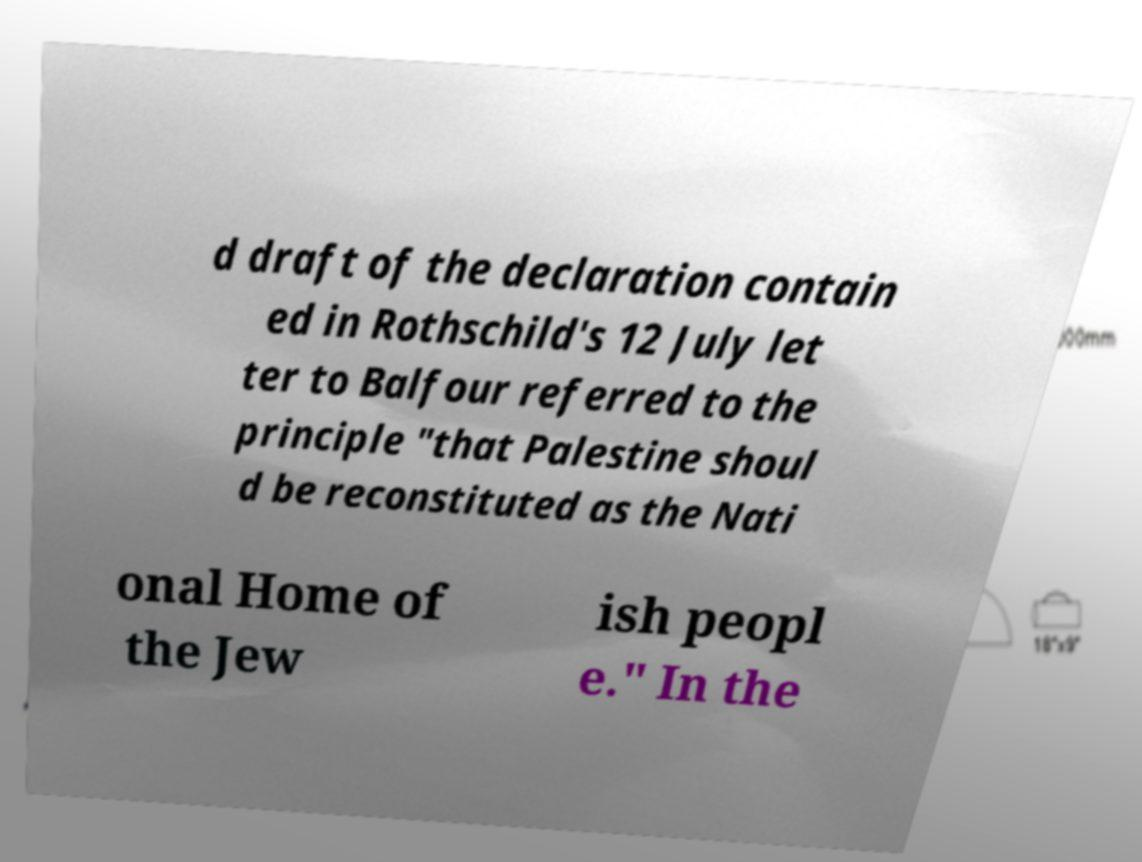Please identify and transcribe the text found in this image. d draft of the declaration contain ed in Rothschild's 12 July let ter to Balfour referred to the principle "that Palestine shoul d be reconstituted as the Nati onal Home of the Jew ish peopl e." In the 